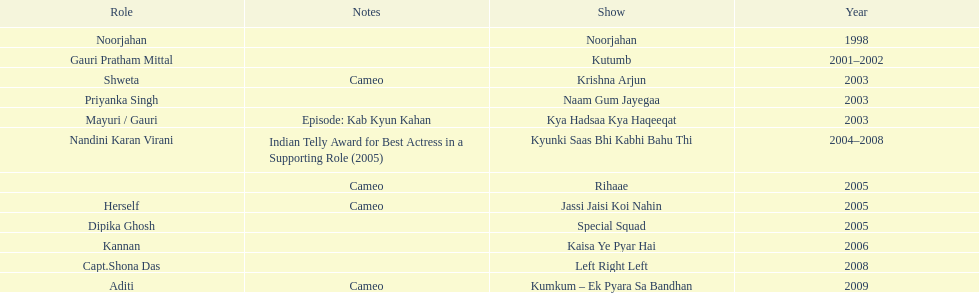Which was the only television show gauri starred in, in which she played herself? Jassi Jaisi Koi Nahin. 